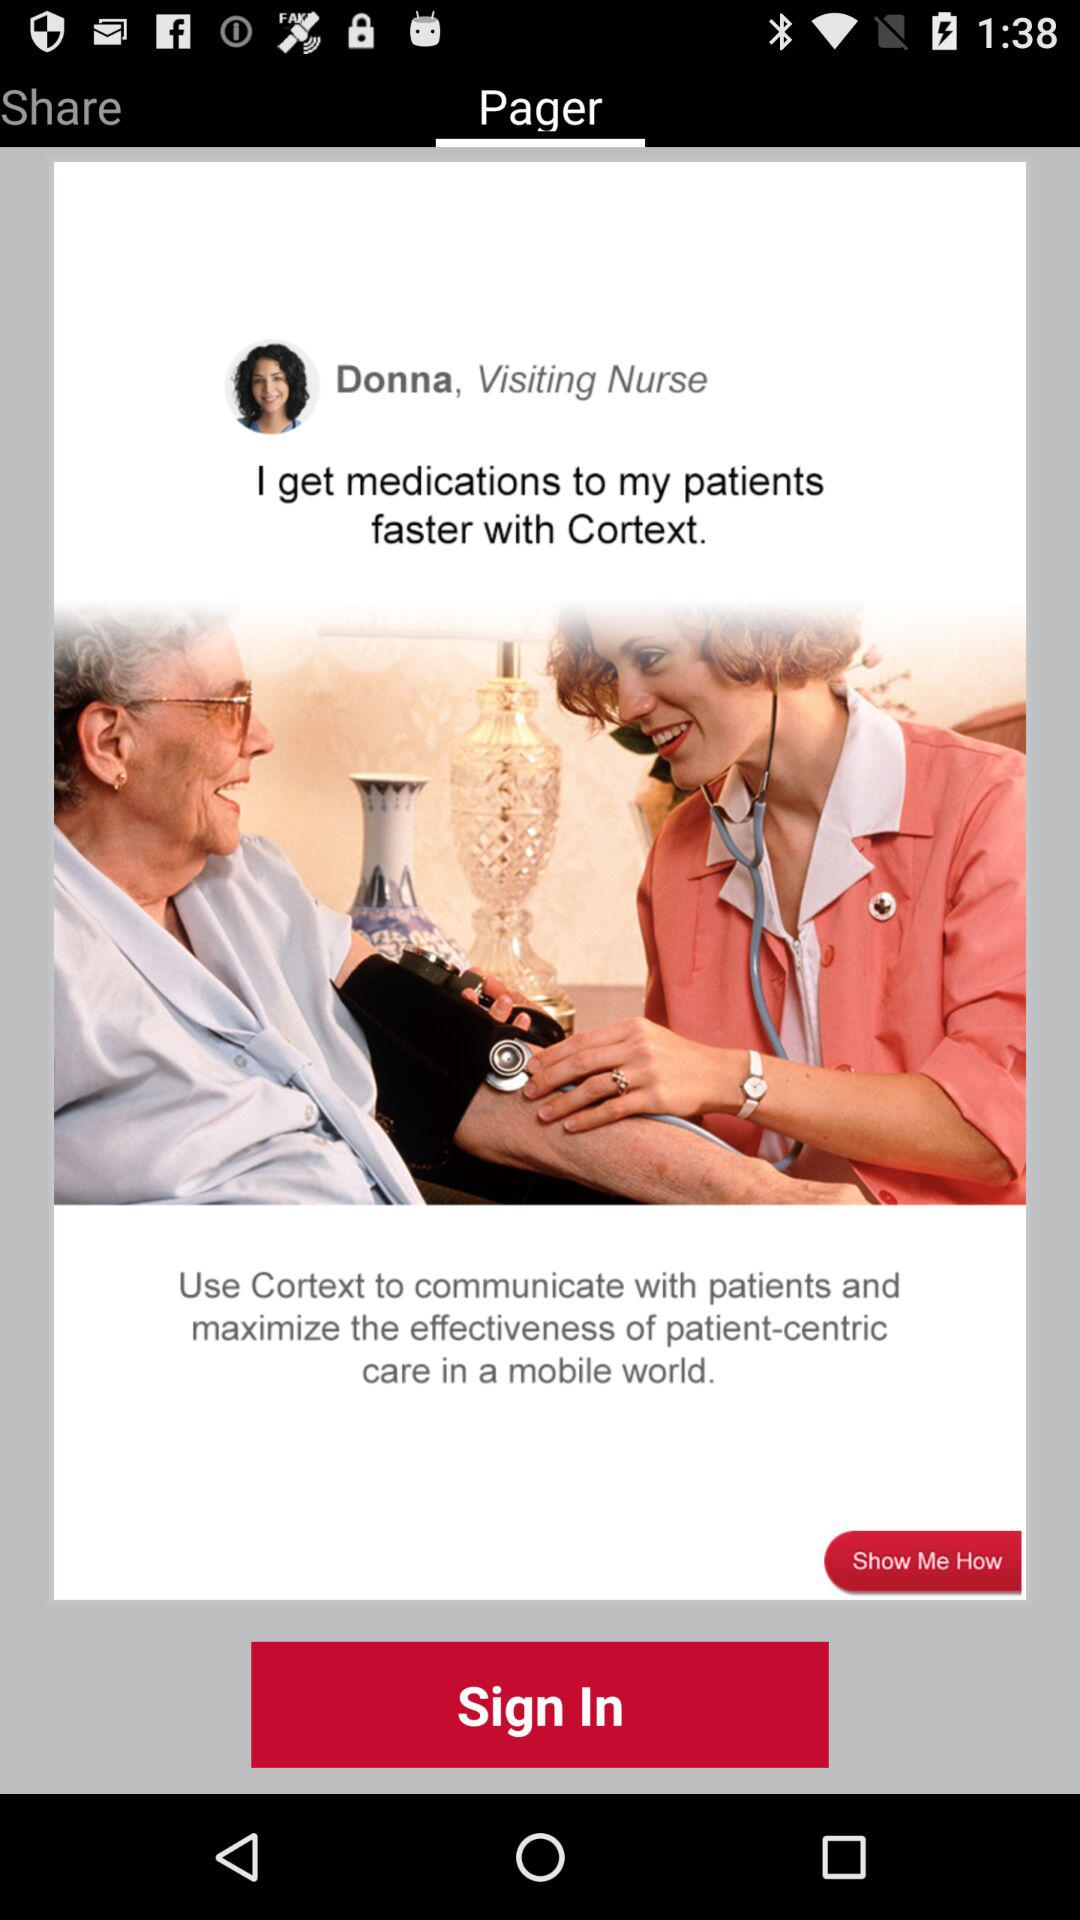Who is the visiting nurse? The visiting nurse is Donna. 